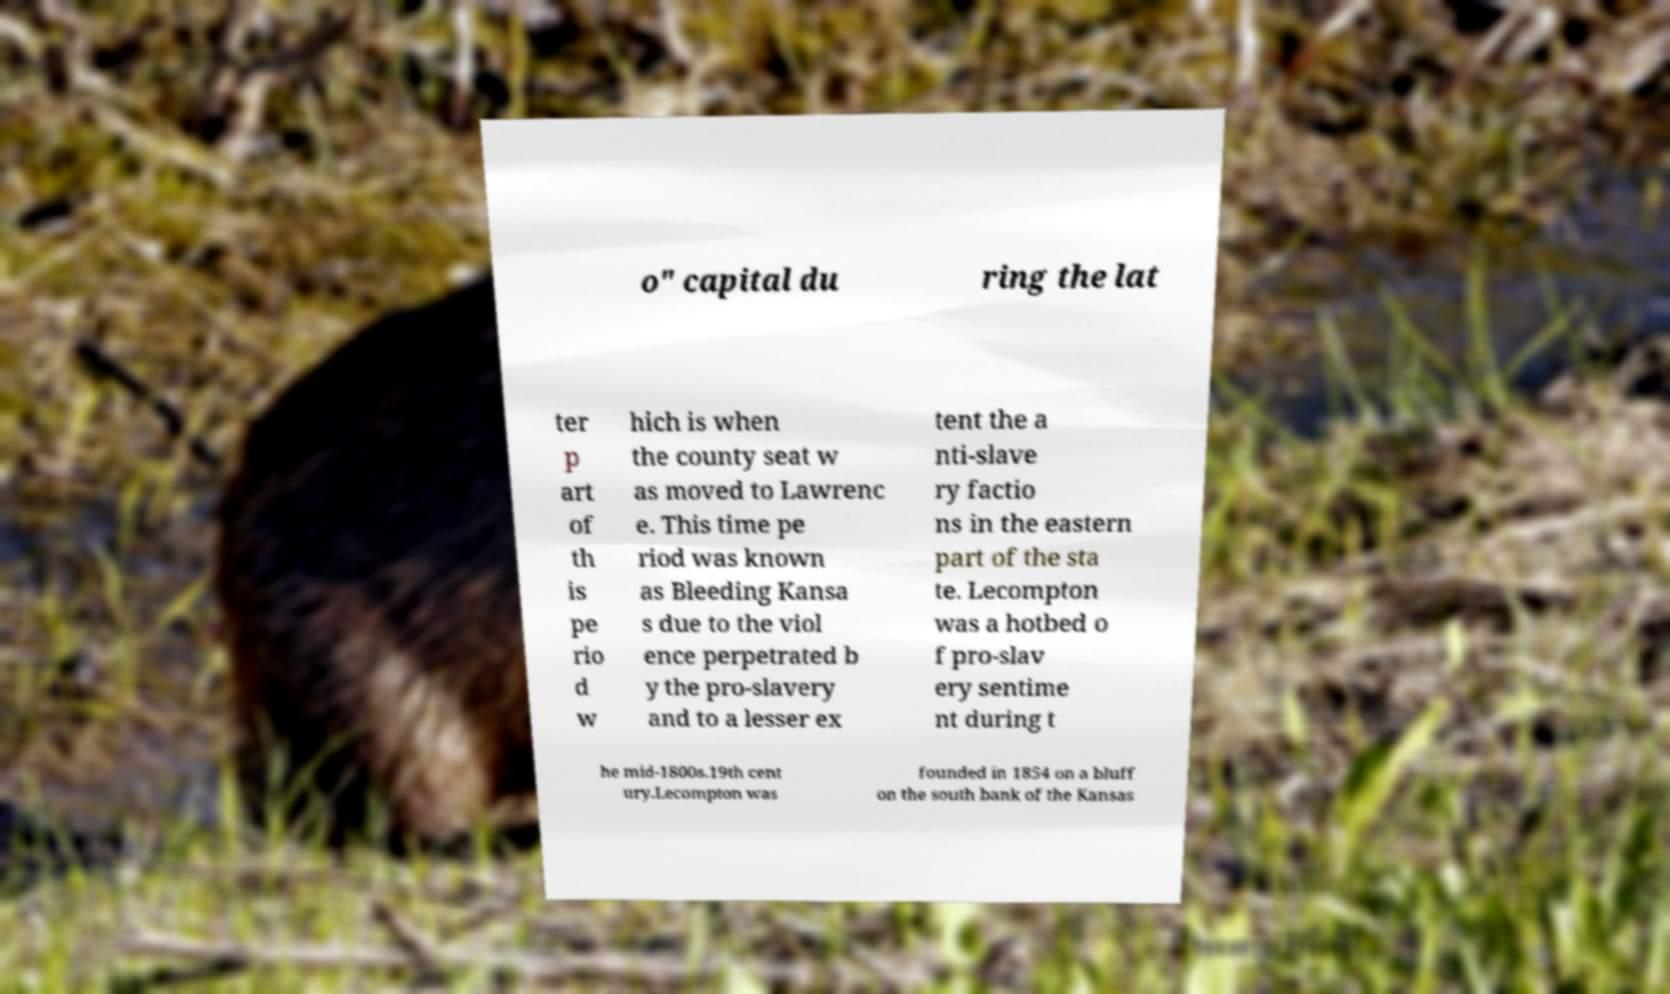Could you assist in decoding the text presented in this image and type it out clearly? o" capital du ring the lat ter p art of th is pe rio d w hich is when the county seat w as moved to Lawrenc e. This time pe riod was known as Bleeding Kansa s due to the viol ence perpetrated b y the pro-slavery and to a lesser ex tent the a nti-slave ry factio ns in the eastern part of the sta te. Lecompton was a hotbed o f pro-slav ery sentime nt during t he mid-1800s.19th cent ury.Lecompton was founded in 1854 on a bluff on the south bank of the Kansas 